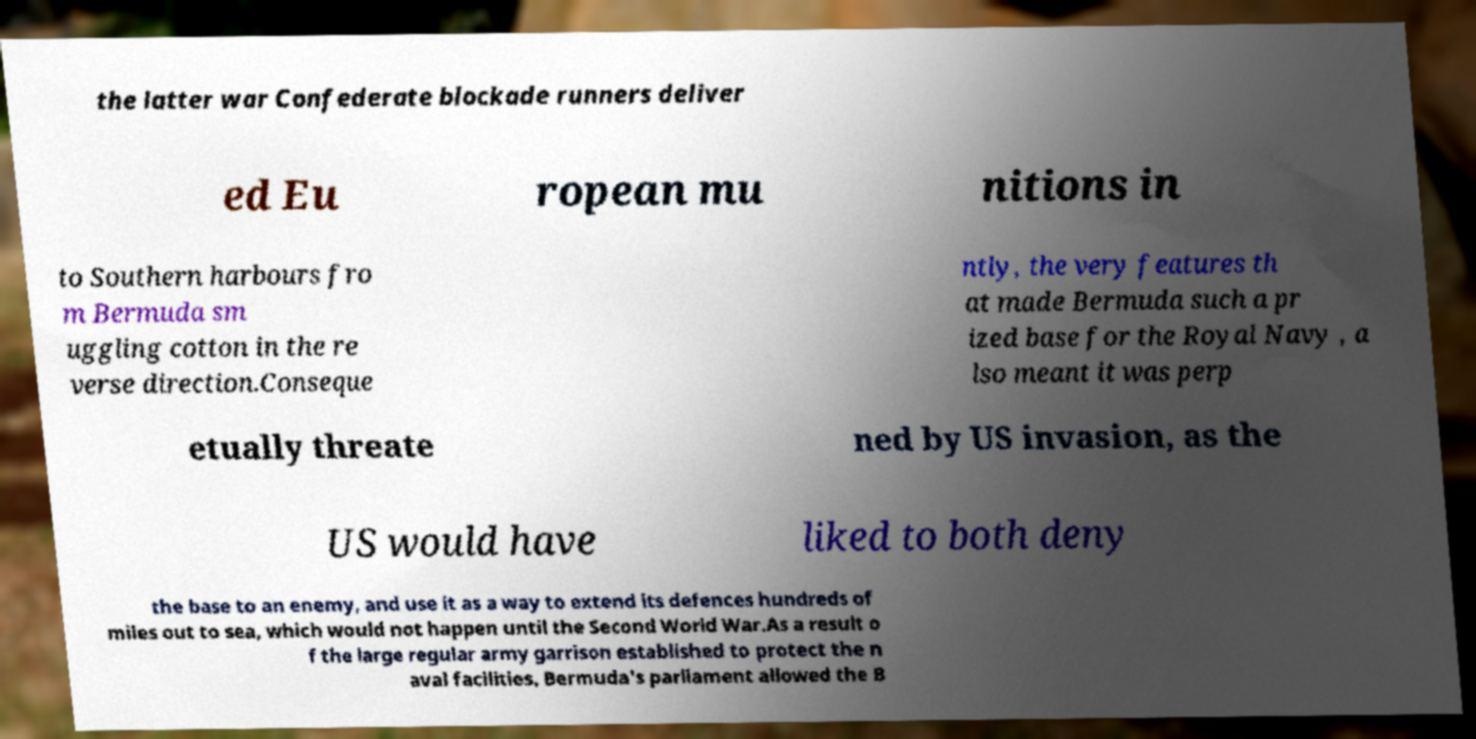I need the written content from this picture converted into text. Can you do that? the latter war Confederate blockade runners deliver ed Eu ropean mu nitions in to Southern harbours fro m Bermuda sm uggling cotton in the re verse direction.Conseque ntly, the very features th at made Bermuda such a pr ized base for the Royal Navy , a lso meant it was perp etually threate ned by US invasion, as the US would have liked to both deny the base to an enemy, and use it as a way to extend its defences hundreds of miles out to sea, which would not happen until the Second World War.As a result o f the large regular army garrison established to protect the n aval facilities, Bermuda's parliament allowed the B 